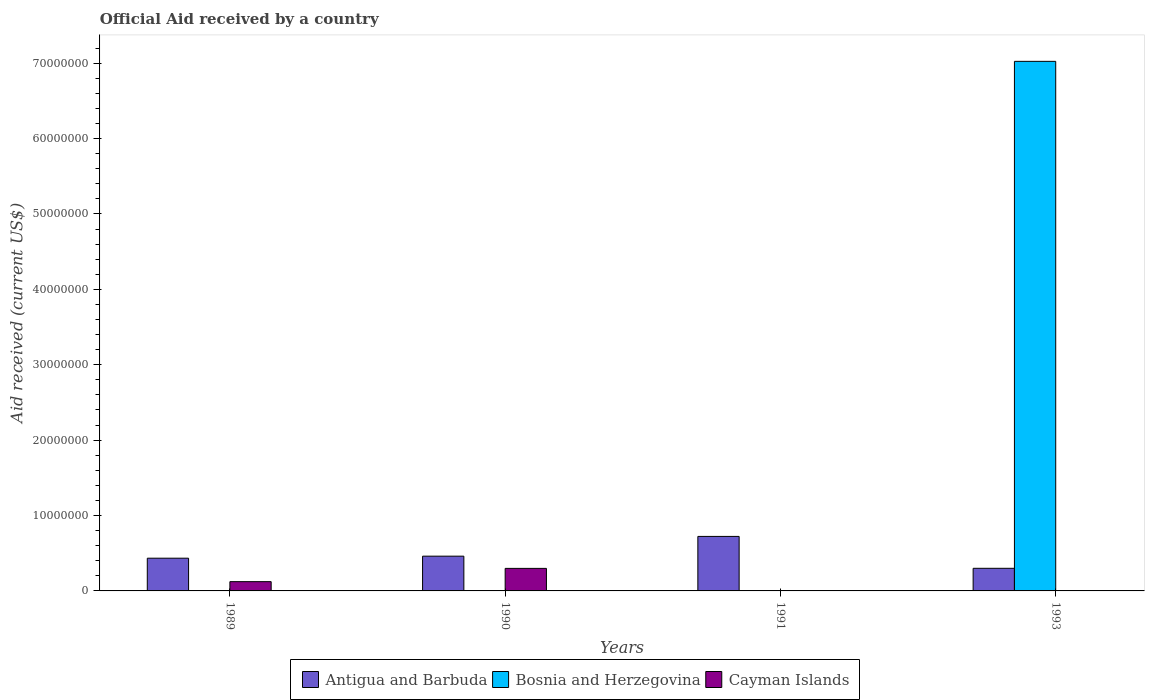Are the number of bars per tick equal to the number of legend labels?
Provide a short and direct response. No. How many bars are there on the 1st tick from the left?
Give a very brief answer. 3. How many bars are there on the 3rd tick from the right?
Give a very brief answer. 3. What is the label of the 3rd group of bars from the left?
Offer a terse response. 1991. In how many cases, is the number of bars for a given year not equal to the number of legend labels?
Keep it short and to the point. 2. What is the net official aid received in Bosnia and Herzegovina in 1989?
Offer a very short reply. 10000. Across all years, what is the maximum net official aid received in Bosnia and Herzegovina?
Keep it short and to the point. 7.02e+07. Across all years, what is the minimum net official aid received in Cayman Islands?
Ensure brevity in your answer.  0. What is the total net official aid received in Bosnia and Herzegovina in the graph?
Provide a succinct answer. 7.03e+07. What is the difference between the net official aid received in Antigua and Barbuda in 1990 and that in 1993?
Provide a succinct answer. 1.61e+06. What is the difference between the net official aid received in Bosnia and Herzegovina in 1989 and the net official aid received in Cayman Islands in 1990?
Your answer should be compact. -2.98e+06. What is the average net official aid received in Bosnia and Herzegovina per year?
Ensure brevity in your answer.  1.76e+07. In the year 1990, what is the difference between the net official aid received in Cayman Islands and net official aid received in Antigua and Barbuda?
Give a very brief answer. -1.62e+06. In how many years, is the net official aid received in Antigua and Barbuda greater than 62000000 US$?
Your response must be concise. 0. What is the ratio of the net official aid received in Cayman Islands in 1989 to that in 1990?
Offer a very short reply. 0.41. Is the net official aid received in Antigua and Barbuda in 1989 less than that in 1993?
Ensure brevity in your answer.  No. Is the difference between the net official aid received in Cayman Islands in 1989 and 1990 greater than the difference between the net official aid received in Antigua and Barbuda in 1989 and 1990?
Offer a terse response. No. What is the difference between the highest and the second highest net official aid received in Bosnia and Herzegovina?
Provide a short and direct response. 7.02e+07. What is the difference between the highest and the lowest net official aid received in Cayman Islands?
Provide a short and direct response. 2.99e+06. Is the sum of the net official aid received in Bosnia and Herzegovina in 1990 and 1993 greater than the maximum net official aid received in Antigua and Barbuda across all years?
Your answer should be compact. Yes. How many bars are there?
Make the answer very short. 10. How many years are there in the graph?
Ensure brevity in your answer.  4. What is the difference between two consecutive major ticks on the Y-axis?
Provide a succinct answer. 1.00e+07. How many legend labels are there?
Provide a succinct answer. 3. What is the title of the graph?
Offer a very short reply. Official Aid received by a country. Does "Belize" appear as one of the legend labels in the graph?
Make the answer very short. No. What is the label or title of the X-axis?
Keep it short and to the point. Years. What is the label or title of the Y-axis?
Your response must be concise. Aid received (current US$). What is the Aid received (current US$) of Antigua and Barbuda in 1989?
Your response must be concise. 4.34e+06. What is the Aid received (current US$) in Bosnia and Herzegovina in 1989?
Your answer should be very brief. 10000. What is the Aid received (current US$) in Cayman Islands in 1989?
Offer a very short reply. 1.23e+06. What is the Aid received (current US$) of Antigua and Barbuda in 1990?
Offer a very short reply. 4.61e+06. What is the Aid received (current US$) in Cayman Islands in 1990?
Provide a succinct answer. 2.99e+06. What is the Aid received (current US$) of Antigua and Barbuda in 1991?
Give a very brief answer. 7.23e+06. What is the Aid received (current US$) of Bosnia and Herzegovina in 1991?
Give a very brief answer. 10000. What is the Aid received (current US$) of Cayman Islands in 1991?
Offer a terse response. 0. What is the Aid received (current US$) in Antigua and Barbuda in 1993?
Offer a very short reply. 3.00e+06. What is the Aid received (current US$) in Bosnia and Herzegovina in 1993?
Give a very brief answer. 7.02e+07. What is the Aid received (current US$) in Cayman Islands in 1993?
Offer a very short reply. 0. Across all years, what is the maximum Aid received (current US$) in Antigua and Barbuda?
Offer a very short reply. 7.23e+06. Across all years, what is the maximum Aid received (current US$) of Bosnia and Herzegovina?
Your answer should be compact. 7.02e+07. Across all years, what is the maximum Aid received (current US$) in Cayman Islands?
Provide a succinct answer. 2.99e+06. Across all years, what is the minimum Aid received (current US$) in Cayman Islands?
Your response must be concise. 0. What is the total Aid received (current US$) of Antigua and Barbuda in the graph?
Keep it short and to the point. 1.92e+07. What is the total Aid received (current US$) in Bosnia and Herzegovina in the graph?
Keep it short and to the point. 7.03e+07. What is the total Aid received (current US$) of Cayman Islands in the graph?
Provide a short and direct response. 4.22e+06. What is the difference between the Aid received (current US$) of Bosnia and Herzegovina in 1989 and that in 1990?
Give a very brief answer. 0. What is the difference between the Aid received (current US$) in Cayman Islands in 1989 and that in 1990?
Your response must be concise. -1.76e+06. What is the difference between the Aid received (current US$) of Antigua and Barbuda in 1989 and that in 1991?
Your response must be concise. -2.89e+06. What is the difference between the Aid received (current US$) of Bosnia and Herzegovina in 1989 and that in 1991?
Offer a terse response. 0. What is the difference between the Aid received (current US$) in Antigua and Barbuda in 1989 and that in 1993?
Keep it short and to the point. 1.34e+06. What is the difference between the Aid received (current US$) of Bosnia and Herzegovina in 1989 and that in 1993?
Provide a short and direct response. -7.02e+07. What is the difference between the Aid received (current US$) of Antigua and Barbuda in 1990 and that in 1991?
Provide a succinct answer. -2.62e+06. What is the difference between the Aid received (current US$) in Antigua and Barbuda in 1990 and that in 1993?
Provide a short and direct response. 1.61e+06. What is the difference between the Aid received (current US$) in Bosnia and Herzegovina in 1990 and that in 1993?
Offer a very short reply. -7.02e+07. What is the difference between the Aid received (current US$) of Antigua and Barbuda in 1991 and that in 1993?
Make the answer very short. 4.23e+06. What is the difference between the Aid received (current US$) in Bosnia and Herzegovina in 1991 and that in 1993?
Ensure brevity in your answer.  -7.02e+07. What is the difference between the Aid received (current US$) of Antigua and Barbuda in 1989 and the Aid received (current US$) of Bosnia and Herzegovina in 1990?
Give a very brief answer. 4.33e+06. What is the difference between the Aid received (current US$) in Antigua and Barbuda in 1989 and the Aid received (current US$) in Cayman Islands in 1990?
Your answer should be compact. 1.35e+06. What is the difference between the Aid received (current US$) in Bosnia and Herzegovina in 1989 and the Aid received (current US$) in Cayman Islands in 1990?
Your response must be concise. -2.98e+06. What is the difference between the Aid received (current US$) in Antigua and Barbuda in 1989 and the Aid received (current US$) in Bosnia and Herzegovina in 1991?
Ensure brevity in your answer.  4.33e+06. What is the difference between the Aid received (current US$) of Antigua and Barbuda in 1989 and the Aid received (current US$) of Bosnia and Herzegovina in 1993?
Your answer should be very brief. -6.59e+07. What is the difference between the Aid received (current US$) of Antigua and Barbuda in 1990 and the Aid received (current US$) of Bosnia and Herzegovina in 1991?
Give a very brief answer. 4.60e+06. What is the difference between the Aid received (current US$) of Antigua and Barbuda in 1990 and the Aid received (current US$) of Bosnia and Herzegovina in 1993?
Give a very brief answer. -6.56e+07. What is the difference between the Aid received (current US$) of Antigua and Barbuda in 1991 and the Aid received (current US$) of Bosnia and Herzegovina in 1993?
Your response must be concise. -6.30e+07. What is the average Aid received (current US$) in Antigua and Barbuda per year?
Give a very brief answer. 4.80e+06. What is the average Aid received (current US$) of Bosnia and Herzegovina per year?
Ensure brevity in your answer.  1.76e+07. What is the average Aid received (current US$) of Cayman Islands per year?
Your answer should be very brief. 1.06e+06. In the year 1989, what is the difference between the Aid received (current US$) in Antigua and Barbuda and Aid received (current US$) in Bosnia and Herzegovina?
Your answer should be compact. 4.33e+06. In the year 1989, what is the difference between the Aid received (current US$) in Antigua and Barbuda and Aid received (current US$) in Cayman Islands?
Provide a short and direct response. 3.11e+06. In the year 1989, what is the difference between the Aid received (current US$) in Bosnia and Herzegovina and Aid received (current US$) in Cayman Islands?
Give a very brief answer. -1.22e+06. In the year 1990, what is the difference between the Aid received (current US$) in Antigua and Barbuda and Aid received (current US$) in Bosnia and Herzegovina?
Give a very brief answer. 4.60e+06. In the year 1990, what is the difference between the Aid received (current US$) of Antigua and Barbuda and Aid received (current US$) of Cayman Islands?
Provide a succinct answer. 1.62e+06. In the year 1990, what is the difference between the Aid received (current US$) of Bosnia and Herzegovina and Aid received (current US$) of Cayman Islands?
Your answer should be compact. -2.98e+06. In the year 1991, what is the difference between the Aid received (current US$) in Antigua and Barbuda and Aid received (current US$) in Bosnia and Herzegovina?
Offer a very short reply. 7.22e+06. In the year 1993, what is the difference between the Aid received (current US$) of Antigua and Barbuda and Aid received (current US$) of Bosnia and Herzegovina?
Make the answer very short. -6.72e+07. What is the ratio of the Aid received (current US$) of Antigua and Barbuda in 1989 to that in 1990?
Your answer should be very brief. 0.94. What is the ratio of the Aid received (current US$) in Cayman Islands in 1989 to that in 1990?
Your response must be concise. 0.41. What is the ratio of the Aid received (current US$) of Antigua and Barbuda in 1989 to that in 1991?
Your answer should be very brief. 0.6. What is the ratio of the Aid received (current US$) in Antigua and Barbuda in 1989 to that in 1993?
Ensure brevity in your answer.  1.45. What is the ratio of the Aid received (current US$) in Antigua and Barbuda in 1990 to that in 1991?
Give a very brief answer. 0.64. What is the ratio of the Aid received (current US$) in Bosnia and Herzegovina in 1990 to that in 1991?
Offer a terse response. 1. What is the ratio of the Aid received (current US$) of Antigua and Barbuda in 1990 to that in 1993?
Provide a succinct answer. 1.54. What is the ratio of the Aid received (current US$) of Antigua and Barbuda in 1991 to that in 1993?
Provide a short and direct response. 2.41. What is the difference between the highest and the second highest Aid received (current US$) of Antigua and Barbuda?
Your answer should be very brief. 2.62e+06. What is the difference between the highest and the second highest Aid received (current US$) of Bosnia and Herzegovina?
Offer a terse response. 7.02e+07. What is the difference between the highest and the lowest Aid received (current US$) in Antigua and Barbuda?
Your answer should be very brief. 4.23e+06. What is the difference between the highest and the lowest Aid received (current US$) of Bosnia and Herzegovina?
Provide a short and direct response. 7.02e+07. What is the difference between the highest and the lowest Aid received (current US$) of Cayman Islands?
Ensure brevity in your answer.  2.99e+06. 